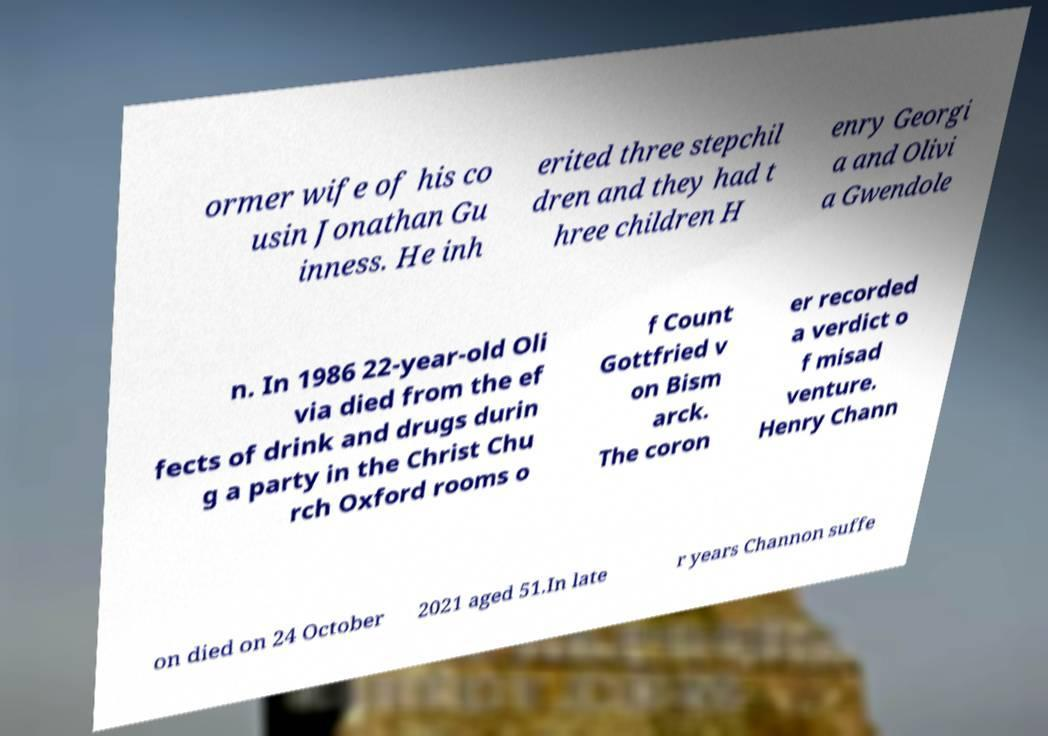Can you read and provide the text displayed in the image?This photo seems to have some interesting text. Can you extract and type it out for me? ormer wife of his co usin Jonathan Gu inness. He inh erited three stepchil dren and they had t hree children H enry Georgi a and Olivi a Gwendole n. In 1986 22-year-old Oli via died from the ef fects of drink and drugs durin g a party in the Christ Chu rch Oxford rooms o f Count Gottfried v on Bism arck. The coron er recorded a verdict o f misad venture. Henry Chann on died on 24 October 2021 aged 51.In late r years Channon suffe 